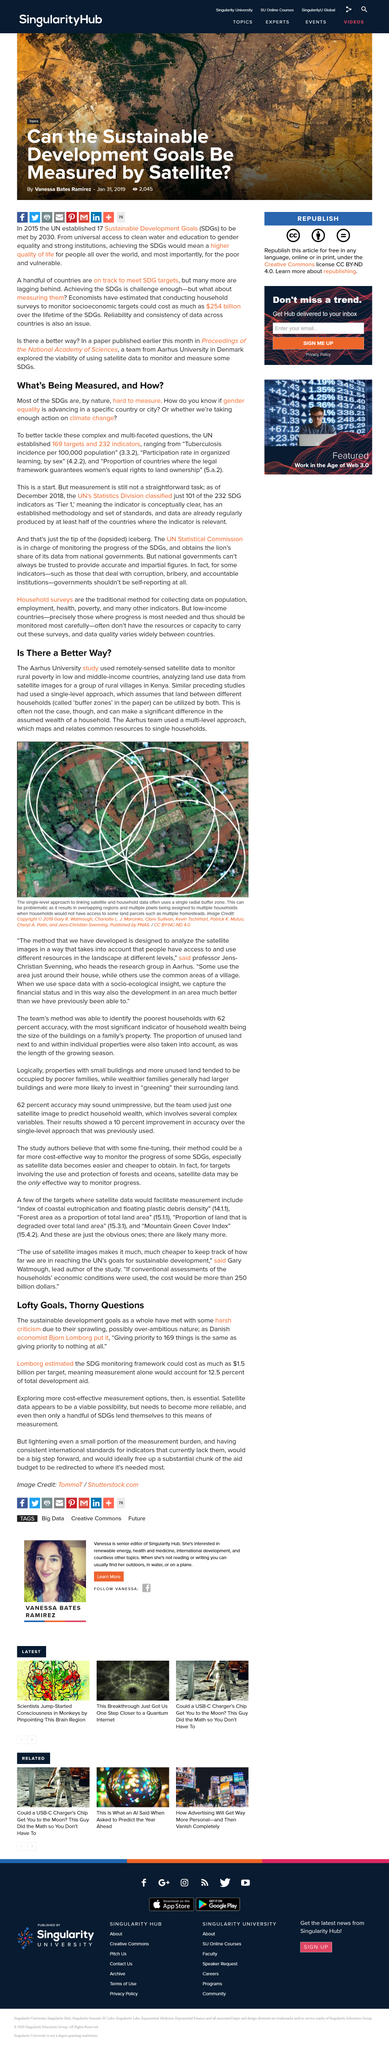Highlight a few significant elements in this photo. The image depicts Kenya, which is visible from above. Yes, the UN has established targets and indicators to combat the issue of the SDGs being hard to measure. In the paper, the land between different households is referred to as 'buffer zones.' The Aarhus team employed a multi-level approach in their research. The United Nations established a total of 169 targets and 232 indicators to measure progress towards achieving sustainable development goals. 